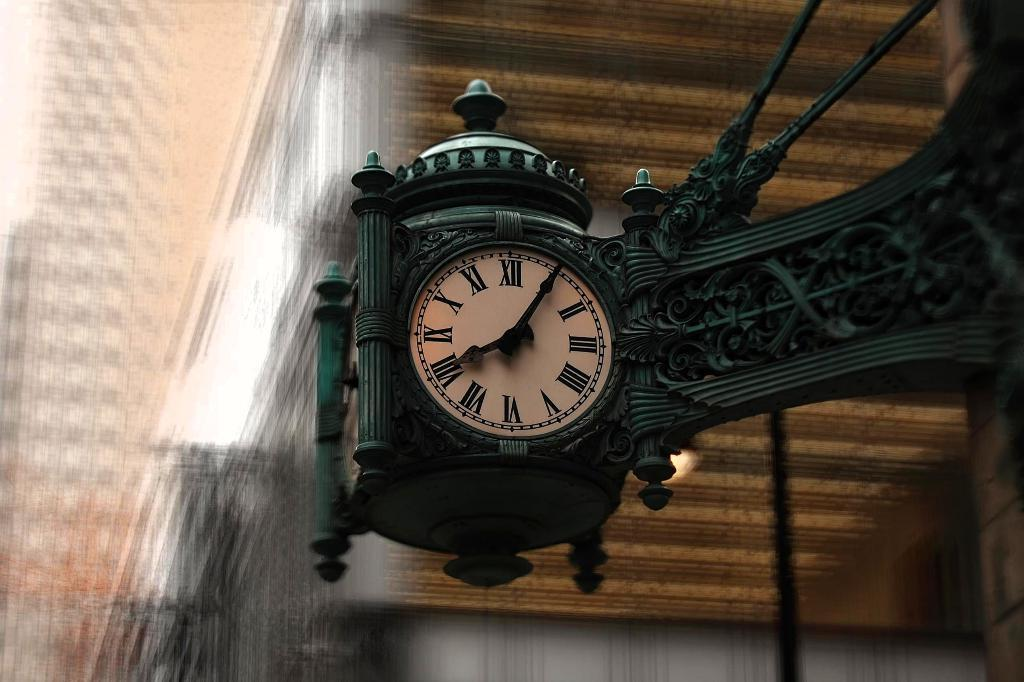<image>
Share a concise interpretation of the image provided. Face of a clock with the hands on the number 1 and 8. 